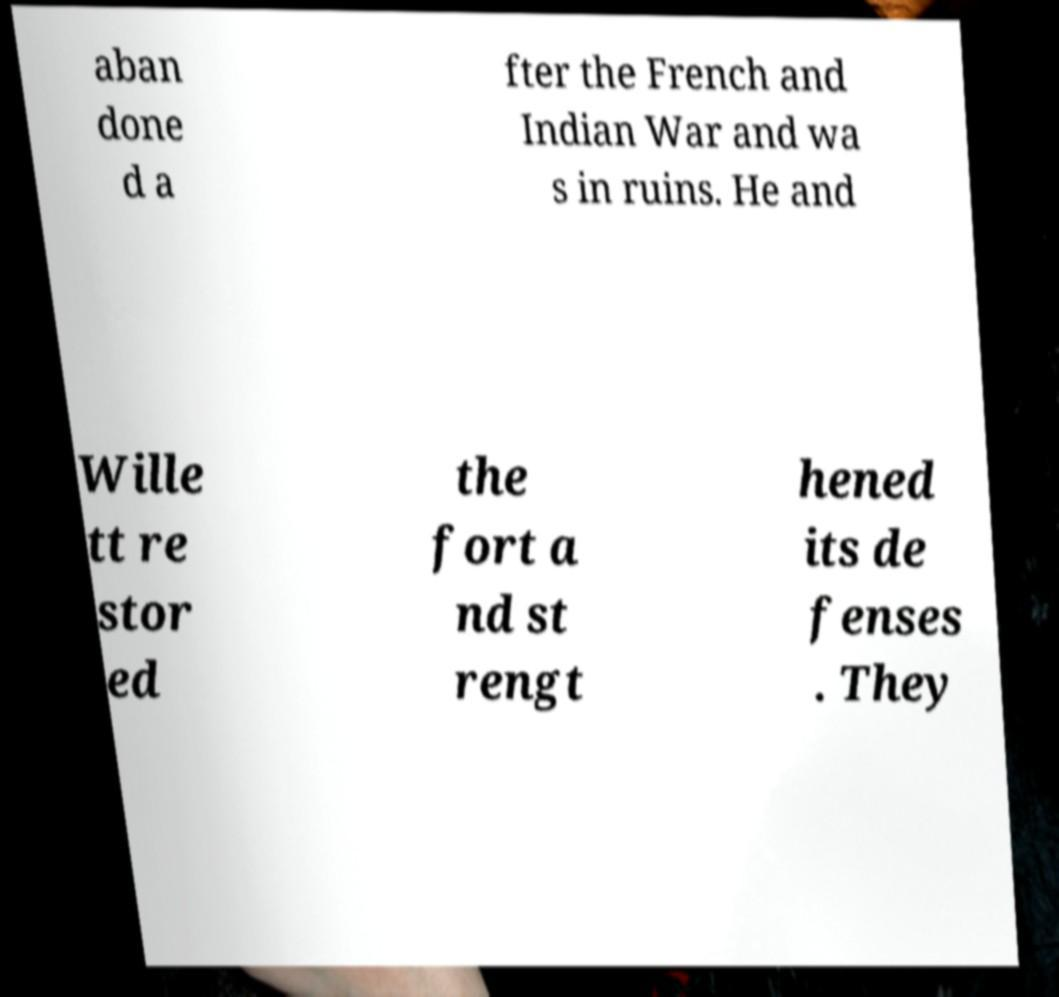Please read and relay the text visible in this image. What does it say? aban done d a fter the French and Indian War and wa s in ruins. He and Wille tt re stor ed the fort a nd st rengt hened its de fenses . They 